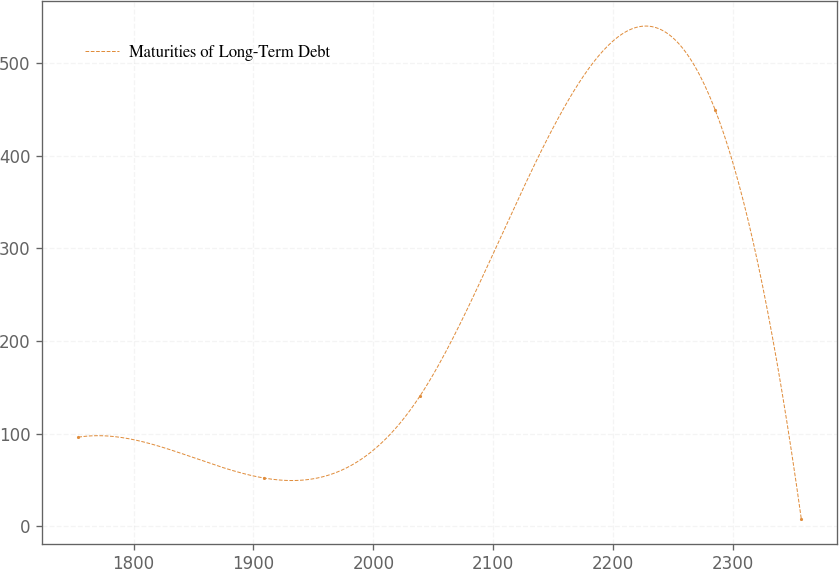Convert chart. <chart><loc_0><loc_0><loc_500><loc_500><line_chart><ecel><fcel>Maturities of Long-Term Debt<nl><fcel>1753.87<fcel>96.36<nl><fcel>1909.17<fcel>52.16<nl><fcel>2038.75<fcel>140.56<nl><fcel>2284.97<fcel>449.95<nl><fcel>2356.93<fcel>7.96<nl></chart> 